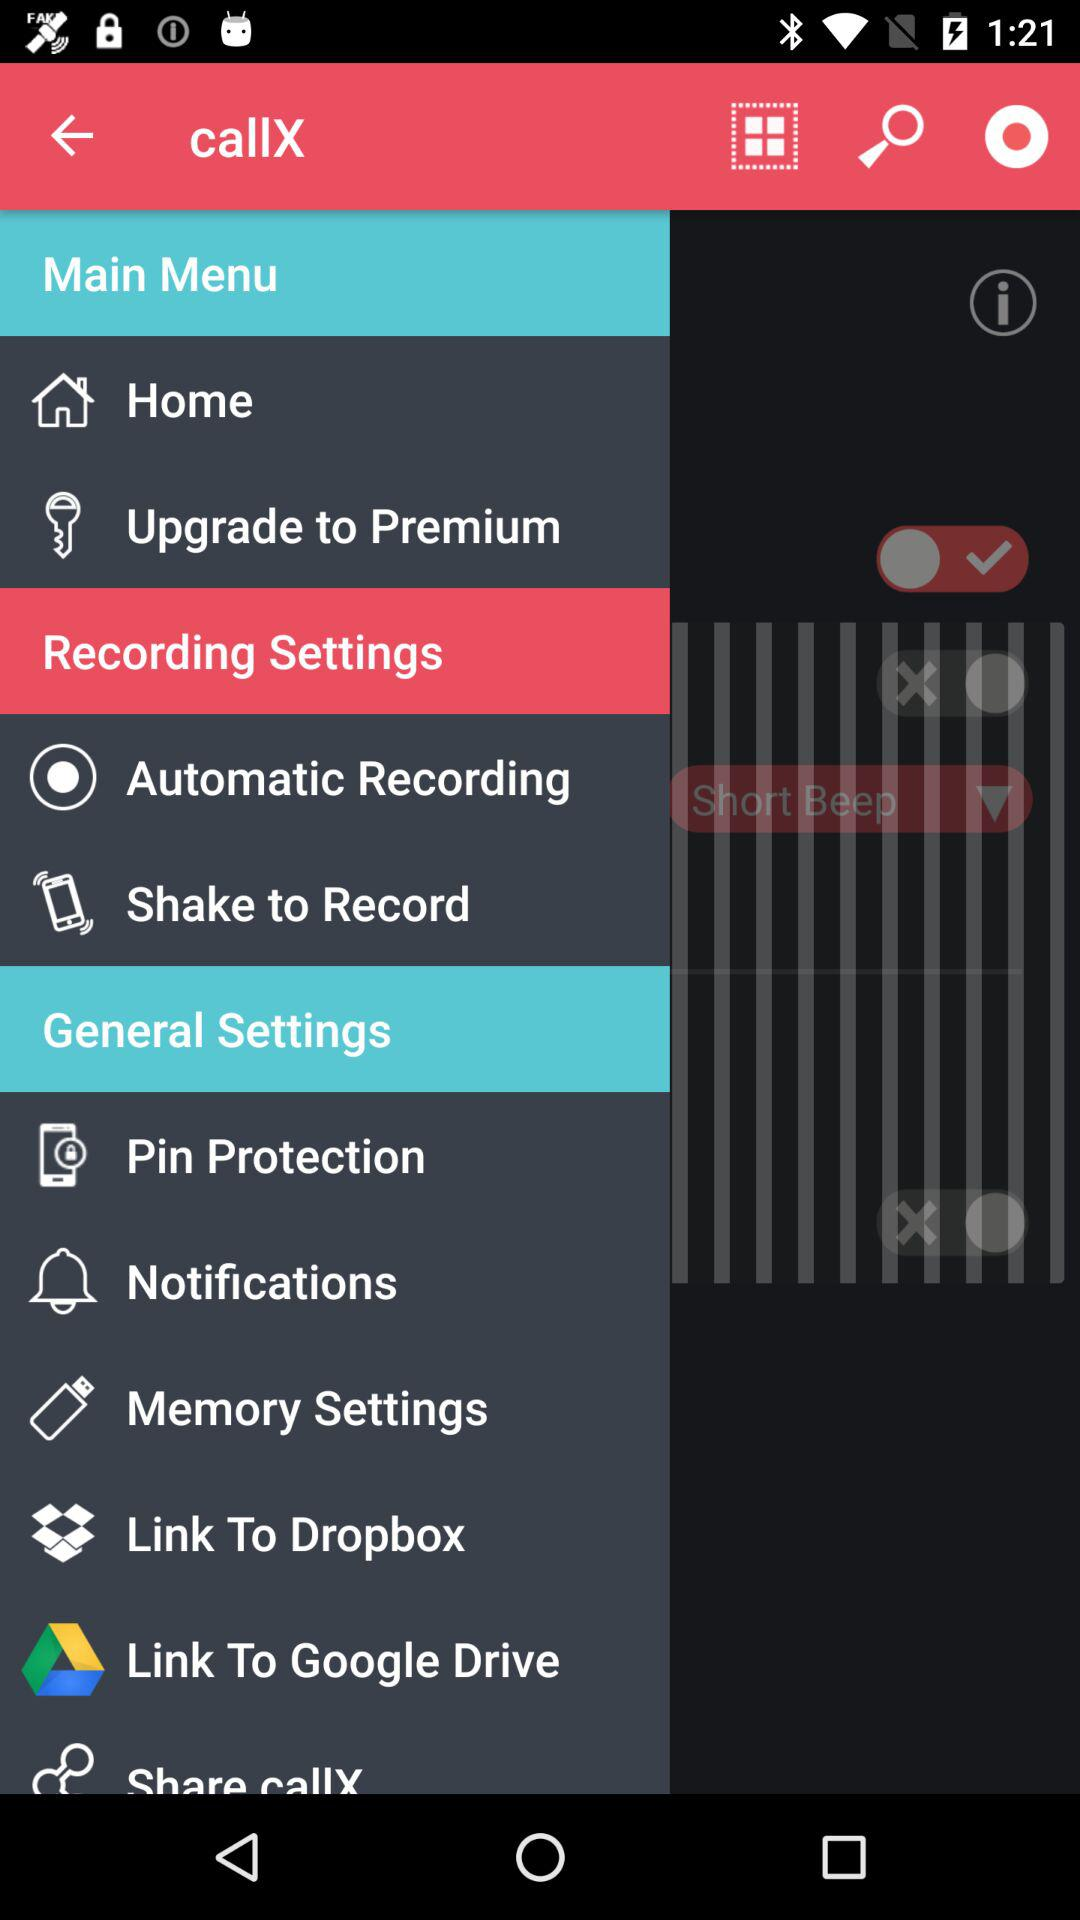How many more items are in the General Settings section than in the Recording Settings section?
Answer the question using a single word or phrase. 4 